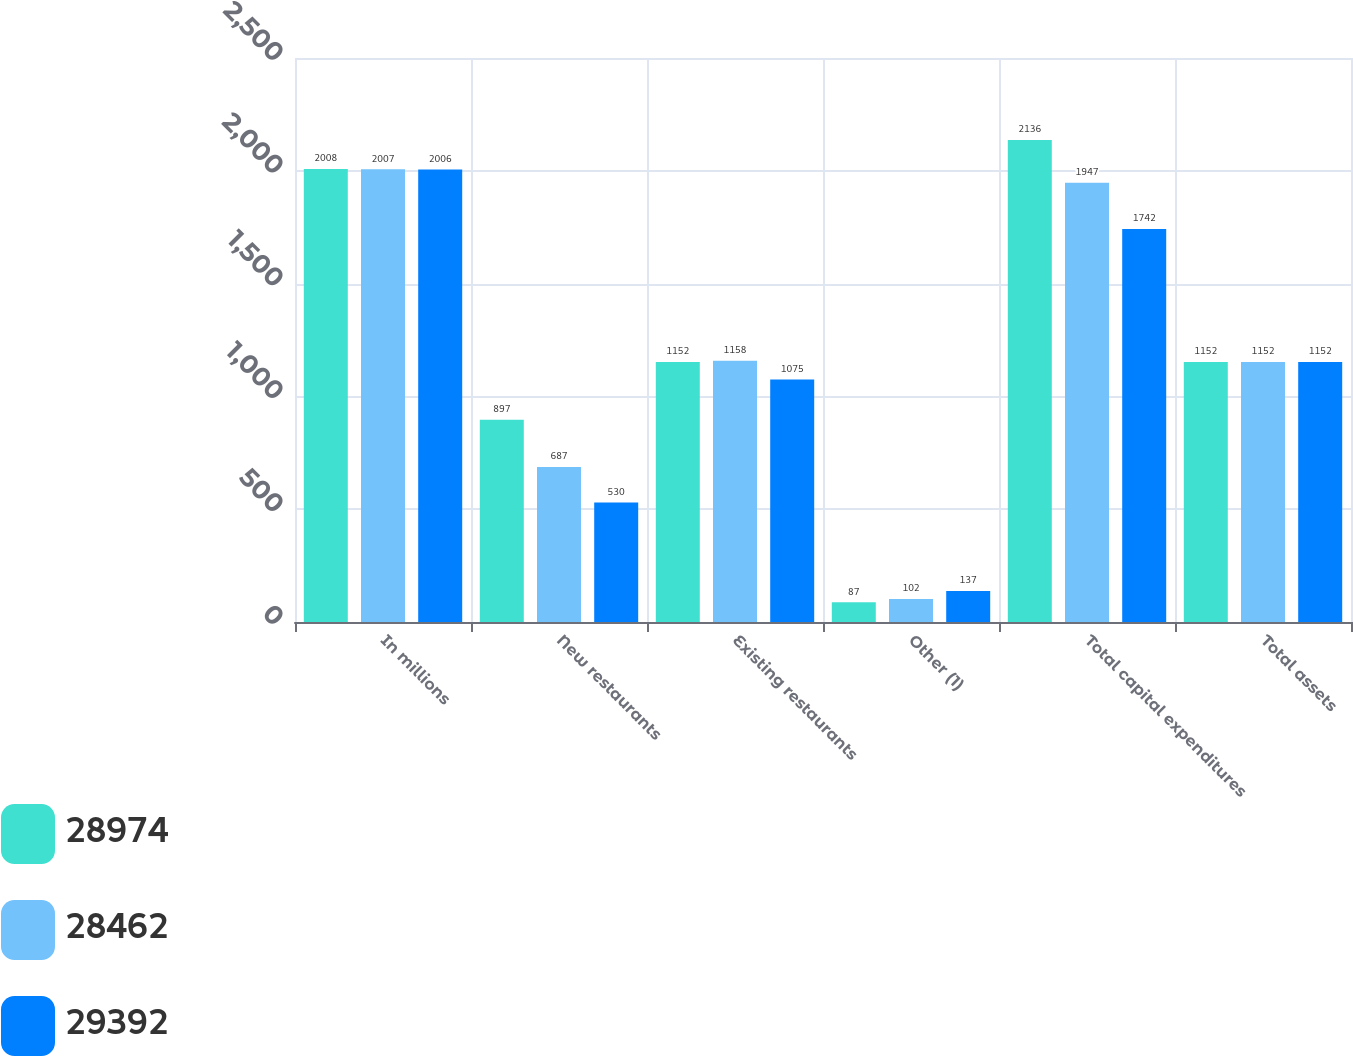<chart> <loc_0><loc_0><loc_500><loc_500><stacked_bar_chart><ecel><fcel>In millions<fcel>New restaurants<fcel>Existing restaurants<fcel>Other (1)<fcel>Total capital expenditures<fcel>Total assets<nl><fcel>28974<fcel>2008<fcel>897<fcel>1152<fcel>87<fcel>2136<fcel>1152<nl><fcel>28462<fcel>2007<fcel>687<fcel>1158<fcel>102<fcel>1947<fcel>1152<nl><fcel>29392<fcel>2006<fcel>530<fcel>1075<fcel>137<fcel>1742<fcel>1152<nl></chart> 